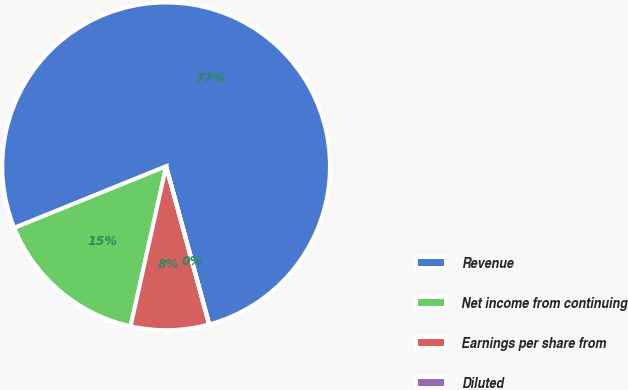Convert chart. <chart><loc_0><loc_0><loc_500><loc_500><pie_chart><fcel>Revenue<fcel>Net income from continuing<fcel>Earnings per share from<fcel>Diluted<nl><fcel>76.89%<fcel>15.39%<fcel>7.7%<fcel>0.02%<nl></chart> 